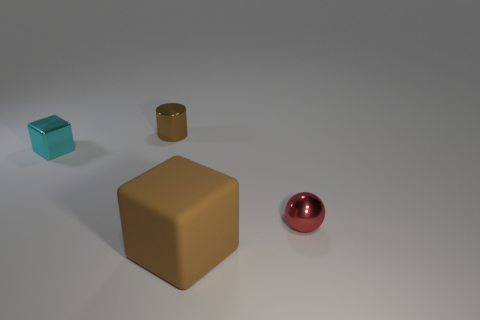How are the shadows of the objects oriented in relation to the light source? The shadows of the objects are cast to the right side of the image, which suggests that the primary light source is positioned to the left of the scene. Each object's shadow aligns with its shape, indicating a singular and consistent light source. 